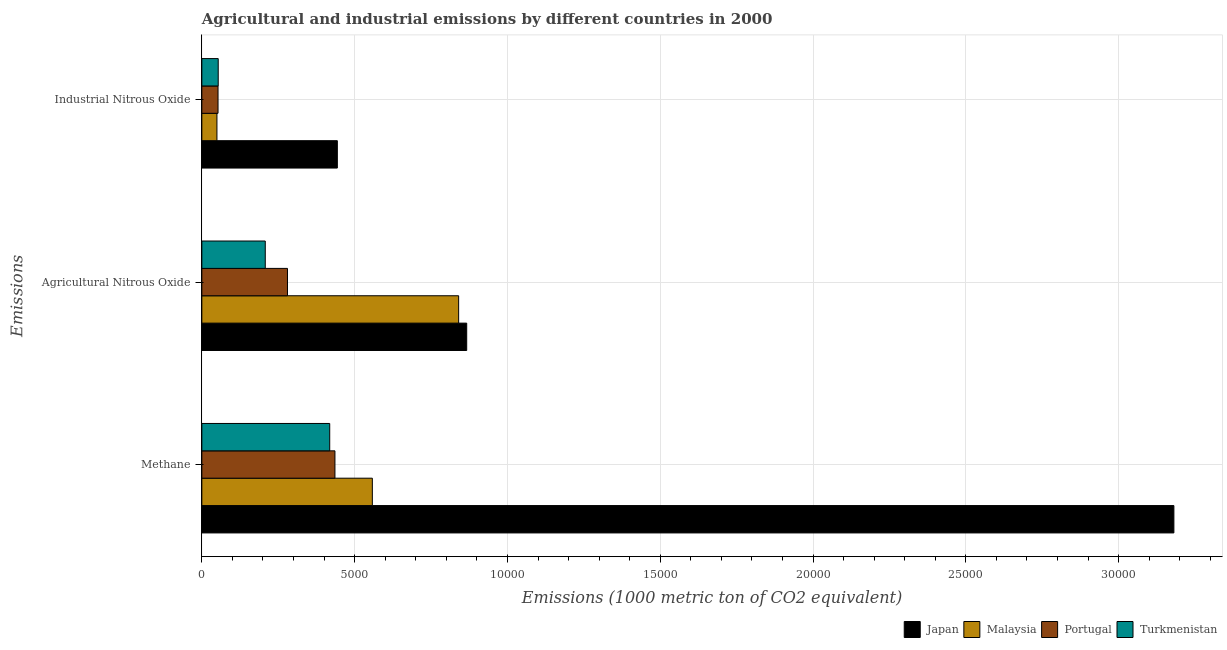How many different coloured bars are there?
Offer a very short reply. 4. What is the label of the 1st group of bars from the top?
Give a very brief answer. Industrial Nitrous Oxide. What is the amount of agricultural nitrous oxide emissions in Japan?
Provide a short and direct response. 8667.2. Across all countries, what is the maximum amount of industrial nitrous oxide emissions?
Give a very brief answer. 4433.9. Across all countries, what is the minimum amount of methane emissions?
Ensure brevity in your answer.  4184.3. In which country was the amount of industrial nitrous oxide emissions maximum?
Ensure brevity in your answer.  Japan. In which country was the amount of methane emissions minimum?
Give a very brief answer. Turkmenistan. What is the total amount of industrial nitrous oxide emissions in the graph?
Make the answer very short. 5992.9. What is the difference between the amount of methane emissions in Malaysia and that in Turkmenistan?
Keep it short and to the point. 1394.9. What is the difference between the amount of methane emissions in Turkmenistan and the amount of agricultural nitrous oxide emissions in Japan?
Your answer should be compact. -4482.9. What is the average amount of agricultural nitrous oxide emissions per country?
Keep it short and to the point. 5487.03. What is the difference between the amount of methane emissions and amount of agricultural nitrous oxide emissions in Turkmenistan?
Provide a short and direct response. 2109. In how many countries, is the amount of methane emissions greater than 7000 metric ton?
Provide a succinct answer. 1. What is the ratio of the amount of methane emissions in Japan to that in Turkmenistan?
Provide a succinct answer. 7.6. Is the difference between the amount of methane emissions in Malaysia and Turkmenistan greater than the difference between the amount of industrial nitrous oxide emissions in Malaysia and Turkmenistan?
Your answer should be compact. Yes. What is the difference between the highest and the second highest amount of industrial nitrous oxide emissions?
Your answer should be very brief. 3898.2. What is the difference between the highest and the lowest amount of industrial nitrous oxide emissions?
Your answer should be compact. 3940.1. In how many countries, is the amount of agricultural nitrous oxide emissions greater than the average amount of agricultural nitrous oxide emissions taken over all countries?
Offer a terse response. 2. What does the 1st bar from the bottom in Methane represents?
Your answer should be very brief. Japan. How many bars are there?
Make the answer very short. 12. Are all the bars in the graph horizontal?
Give a very brief answer. Yes. What is the difference between two consecutive major ticks on the X-axis?
Your answer should be compact. 5000. Are the values on the major ticks of X-axis written in scientific E-notation?
Your response must be concise. No. Does the graph contain grids?
Give a very brief answer. Yes. Where does the legend appear in the graph?
Offer a very short reply. Bottom right. What is the title of the graph?
Your response must be concise. Agricultural and industrial emissions by different countries in 2000. What is the label or title of the X-axis?
Offer a terse response. Emissions (1000 metric ton of CO2 equivalent). What is the label or title of the Y-axis?
Offer a very short reply. Emissions. What is the Emissions (1000 metric ton of CO2 equivalent) of Japan in Methane?
Give a very brief answer. 3.18e+04. What is the Emissions (1000 metric ton of CO2 equivalent) of Malaysia in Methane?
Your answer should be very brief. 5579.2. What is the Emissions (1000 metric ton of CO2 equivalent) in Portugal in Methane?
Ensure brevity in your answer.  4355.4. What is the Emissions (1000 metric ton of CO2 equivalent) of Turkmenistan in Methane?
Your answer should be compact. 4184.3. What is the Emissions (1000 metric ton of CO2 equivalent) of Japan in Agricultural Nitrous Oxide?
Provide a succinct answer. 8667.2. What is the Emissions (1000 metric ton of CO2 equivalent) of Malaysia in Agricultural Nitrous Oxide?
Keep it short and to the point. 8403.2. What is the Emissions (1000 metric ton of CO2 equivalent) of Portugal in Agricultural Nitrous Oxide?
Your answer should be compact. 2802.4. What is the Emissions (1000 metric ton of CO2 equivalent) in Turkmenistan in Agricultural Nitrous Oxide?
Provide a short and direct response. 2075.3. What is the Emissions (1000 metric ton of CO2 equivalent) of Japan in Industrial Nitrous Oxide?
Give a very brief answer. 4433.9. What is the Emissions (1000 metric ton of CO2 equivalent) in Malaysia in Industrial Nitrous Oxide?
Make the answer very short. 493.8. What is the Emissions (1000 metric ton of CO2 equivalent) of Portugal in Industrial Nitrous Oxide?
Ensure brevity in your answer.  529.5. What is the Emissions (1000 metric ton of CO2 equivalent) of Turkmenistan in Industrial Nitrous Oxide?
Keep it short and to the point. 535.7. Across all Emissions, what is the maximum Emissions (1000 metric ton of CO2 equivalent) in Japan?
Provide a short and direct response. 3.18e+04. Across all Emissions, what is the maximum Emissions (1000 metric ton of CO2 equivalent) in Malaysia?
Offer a very short reply. 8403.2. Across all Emissions, what is the maximum Emissions (1000 metric ton of CO2 equivalent) in Portugal?
Your answer should be compact. 4355.4. Across all Emissions, what is the maximum Emissions (1000 metric ton of CO2 equivalent) in Turkmenistan?
Keep it short and to the point. 4184.3. Across all Emissions, what is the minimum Emissions (1000 metric ton of CO2 equivalent) in Japan?
Your answer should be compact. 4433.9. Across all Emissions, what is the minimum Emissions (1000 metric ton of CO2 equivalent) of Malaysia?
Ensure brevity in your answer.  493.8. Across all Emissions, what is the minimum Emissions (1000 metric ton of CO2 equivalent) of Portugal?
Offer a terse response. 529.5. Across all Emissions, what is the minimum Emissions (1000 metric ton of CO2 equivalent) of Turkmenistan?
Your answer should be very brief. 535.7. What is the total Emissions (1000 metric ton of CO2 equivalent) of Japan in the graph?
Give a very brief answer. 4.49e+04. What is the total Emissions (1000 metric ton of CO2 equivalent) of Malaysia in the graph?
Provide a short and direct response. 1.45e+04. What is the total Emissions (1000 metric ton of CO2 equivalent) in Portugal in the graph?
Your response must be concise. 7687.3. What is the total Emissions (1000 metric ton of CO2 equivalent) in Turkmenistan in the graph?
Your response must be concise. 6795.3. What is the difference between the Emissions (1000 metric ton of CO2 equivalent) of Japan in Methane and that in Agricultural Nitrous Oxide?
Make the answer very short. 2.31e+04. What is the difference between the Emissions (1000 metric ton of CO2 equivalent) in Malaysia in Methane and that in Agricultural Nitrous Oxide?
Ensure brevity in your answer.  -2824. What is the difference between the Emissions (1000 metric ton of CO2 equivalent) of Portugal in Methane and that in Agricultural Nitrous Oxide?
Keep it short and to the point. 1553. What is the difference between the Emissions (1000 metric ton of CO2 equivalent) of Turkmenistan in Methane and that in Agricultural Nitrous Oxide?
Keep it short and to the point. 2109. What is the difference between the Emissions (1000 metric ton of CO2 equivalent) in Japan in Methane and that in Industrial Nitrous Oxide?
Provide a succinct answer. 2.74e+04. What is the difference between the Emissions (1000 metric ton of CO2 equivalent) in Malaysia in Methane and that in Industrial Nitrous Oxide?
Offer a very short reply. 5085.4. What is the difference between the Emissions (1000 metric ton of CO2 equivalent) in Portugal in Methane and that in Industrial Nitrous Oxide?
Offer a very short reply. 3825.9. What is the difference between the Emissions (1000 metric ton of CO2 equivalent) of Turkmenistan in Methane and that in Industrial Nitrous Oxide?
Keep it short and to the point. 3648.6. What is the difference between the Emissions (1000 metric ton of CO2 equivalent) of Japan in Agricultural Nitrous Oxide and that in Industrial Nitrous Oxide?
Make the answer very short. 4233.3. What is the difference between the Emissions (1000 metric ton of CO2 equivalent) in Malaysia in Agricultural Nitrous Oxide and that in Industrial Nitrous Oxide?
Offer a terse response. 7909.4. What is the difference between the Emissions (1000 metric ton of CO2 equivalent) in Portugal in Agricultural Nitrous Oxide and that in Industrial Nitrous Oxide?
Your response must be concise. 2272.9. What is the difference between the Emissions (1000 metric ton of CO2 equivalent) of Turkmenistan in Agricultural Nitrous Oxide and that in Industrial Nitrous Oxide?
Your answer should be compact. 1539.6. What is the difference between the Emissions (1000 metric ton of CO2 equivalent) of Japan in Methane and the Emissions (1000 metric ton of CO2 equivalent) of Malaysia in Agricultural Nitrous Oxide?
Offer a very short reply. 2.34e+04. What is the difference between the Emissions (1000 metric ton of CO2 equivalent) in Japan in Methane and the Emissions (1000 metric ton of CO2 equivalent) in Portugal in Agricultural Nitrous Oxide?
Offer a terse response. 2.90e+04. What is the difference between the Emissions (1000 metric ton of CO2 equivalent) of Japan in Methane and the Emissions (1000 metric ton of CO2 equivalent) of Turkmenistan in Agricultural Nitrous Oxide?
Your response must be concise. 2.97e+04. What is the difference between the Emissions (1000 metric ton of CO2 equivalent) of Malaysia in Methane and the Emissions (1000 metric ton of CO2 equivalent) of Portugal in Agricultural Nitrous Oxide?
Your answer should be very brief. 2776.8. What is the difference between the Emissions (1000 metric ton of CO2 equivalent) in Malaysia in Methane and the Emissions (1000 metric ton of CO2 equivalent) in Turkmenistan in Agricultural Nitrous Oxide?
Ensure brevity in your answer.  3503.9. What is the difference between the Emissions (1000 metric ton of CO2 equivalent) in Portugal in Methane and the Emissions (1000 metric ton of CO2 equivalent) in Turkmenistan in Agricultural Nitrous Oxide?
Offer a very short reply. 2280.1. What is the difference between the Emissions (1000 metric ton of CO2 equivalent) in Japan in Methane and the Emissions (1000 metric ton of CO2 equivalent) in Malaysia in Industrial Nitrous Oxide?
Your response must be concise. 3.13e+04. What is the difference between the Emissions (1000 metric ton of CO2 equivalent) in Japan in Methane and the Emissions (1000 metric ton of CO2 equivalent) in Portugal in Industrial Nitrous Oxide?
Make the answer very short. 3.13e+04. What is the difference between the Emissions (1000 metric ton of CO2 equivalent) in Japan in Methane and the Emissions (1000 metric ton of CO2 equivalent) in Turkmenistan in Industrial Nitrous Oxide?
Your answer should be compact. 3.13e+04. What is the difference between the Emissions (1000 metric ton of CO2 equivalent) in Malaysia in Methane and the Emissions (1000 metric ton of CO2 equivalent) in Portugal in Industrial Nitrous Oxide?
Your answer should be very brief. 5049.7. What is the difference between the Emissions (1000 metric ton of CO2 equivalent) in Malaysia in Methane and the Emissions (1000 metric ton of CO2 equivalent) in Turkmenistan in Industrial Nitrous Oxide?
Give a very brief answer. 5043.5. What is the difference between the Emissions (1000 metric ton of CO2 equivalent) in Portugal in Methane and the Emissions (1000 metric ton of CO2 equivalent) in Turkmenistan in Industrial Nitrous Oxide?
Provide a short and direct response. 3819.7. What is the difference between the Emissions (1000 metric ton of CO2 equivalent) in Japan in Agricultural Nitrous Oxide and the Emissions (1000 metric ton of CO2 equivalent) in Malaysia in Industrial Nitrous Oxide?
Offer a very short reply. 8173.4. What is the difference between the Emissions (1000 metric ton of CO2 equivalent) of Japan in Agricultural Nitrous Oxide and the Emissions (1000 metric ton of CO2 equivalent) of Portugal in Industrial Nitrous Oxide?
Keep it short and to the point. 8137.7. What is the difference between the Emissions (1000 metric ton of CO2 equivalent) in Japan in Agricultural Nitrous Oxide and the Emissions (1000 metric ton of CO2 equivalent) in Turkmenistan in Industrial Nitrous Oxide?
Offer a very short reply. 8131.5. What is the difference between the Emissions (1000 metric ton of CO2 equivalent) of Malaysia in Agricultural Nitrous Oxide and the Emissions (1000 metric ton of CO2 equivalent) of Portugal in Industrial Nitrous Oxide?
Your answer should be very brief. 7873.7. What is the difference between the Emissions (1000 metric ton of CO2 equivalent) in Malaysia in Agricultural Nitrous Oxide and the Emissions (1000 metric ton of CO2 equivalent) in Turkmenistan in Industrial Nitrous Oxide?
Keep it short and to the point. 7867.5. What is the difference between the Emissions (1000 metric ton of CO2 equivalent) of Portugal in Agricultural Nitrous Oxide and the Emissions (1000 metric ton of CO2 equivalent) of Turkmenistan in Industrial Nitrous Oxide?
Provide a short and direct response. 2266.7. What is the average Emissions (1000 metric ton of CO2 equivalent) in Japan per Emissions?
Ensure brevity in your answer.  1.50e+04. What is the average Emissions (1000 metric ton of CO2 equivalent) of Malaysia per Emissions?
Ensure brevity in your answer.  4825.4. What is the average Emissions (1000 metric ton of CO2 equivalent) in Portugal per Emissions?
Your answer should be compact. 2562.43. What is the average Emissions (1000 metric ton of CO2 equivalent) in Turkmenistan per Emissions?
Give a very brief answer. 2265.1. What is the difference between the Emissions (1000 metric ton of CO2 equivalent) of Japan and Emissions (1000 metric ton of CO2 equivalent) of Malaysia in Methane?
Give a very brief answer. 2.62e+04. What is the difference between the Emissions (1000 metric ton of CO2 equivalent) in Japan and Emissions (1000 metric ton of CO2 equivalent) in Portugal in Methane?
Your answer should be compact. 2.75e+04. What is the difference between the Emissions (1000 metric ton of CO2 equivalent) of Japan and Emissions (1000 metric ton of CO2 equivalent) of Turkmenistan in Methane?
Ensure brevity in your answer.  2.76e+04. What is the difference between the Emissions (1000 metric ton of CO2 equivalent) of Malaysia and Emissions (1000 metric ton of CO2 equivalent) of Portugal in Methane?
Give a very brief answer. 1223.8. What is the difference between the Emissions (1000 metric ton of CO2 equivalent) in Malaysia and Emissions (1000 metric ton of CO2 equivalent) in Turkmenistan in Methane?
Keep it short and to the point. 1394.9. What is the difference between the Emissions (1000 metric ton of CO2 equivalent) of Portugal and Emissions (1000 metric ton of CO2 equivalent) of Turkmenistan in Methane?
Ensure brevity in your answer.  171.1. What is the difference between the Emissions (1000 metric ton of CO2 equivalent) of Japan and Emissions (1000 metric ton of CO2 equivalent) of Malaysia in Agricultural Nitrous Oxide?
Provide a short and direct response. 264. What is the difference between the Emissions (1000 metric ton of CO2 equivalent) of Japan and Emissions (1000 metric ton of CO2 equivalent) of Portugal in Agricultural Nitrous Oxide?
Offer a very short reply. 5864.8. What is the difference between the Emissions (1000 metric ton of CO2 equivalent) of Japan and Emissions (1000 metric ton of CO2 equivalent) of Turkmenistan in Agricultural Nitrous Oxide?
Keep it short and to the point. 6591.9. What is the difference between the Emissions (1000 metric ton of CO2 equivalent) in Malaysia and Emissions (1000 metric ton of CO2 equivalent) in Portugal in Agricultural Nitrous Oxide?
Offer a very short reply. 5600.8. What is the difference between the Emissions (1000 metric ton of CO2 equivalent) of Malaysia and Emissions (1000 metric ton of CO2 equivalent) of Turkmenistan in Agricultural Nitrous Oxide?
Ensure brevity in your answer.  6327.9. What is the difference between the Emissions (1000 metric ton of CO2 equivalent) of Portugal and Emissions (1000 metric ton of CO2 equivalent) of Turkmenistan in Agricultural Nitrous Oxide?
Provide a short and direct response. 727.1. What is the difference between the Emissions (1000 metric ton of CO2 equivalent) of Japan and Emissions (1000 metric ton of CO2 equivalent) of Malaysia in Industrial Nitrous Oxide?
Provide a succinct answer. 3940.1. What is the difference between the Emissions (1000 metric ton of CO2 equivalent) of Japan and Emissions (1000 metric ton of CO2 equivalent) of Portugal in Industrial Nitrous Oxide?
Give a very brief answer. 3904.4. What is the difference between the Emissions (1000 metric ton of CO2 equivalent) in Japan and Emissions (1000 metric ton of CO2 equivalent) in Turkmenistan in Industrial Nitrous Oxide?
Offer a very short reply. 3898.2. What is the difference between the Emissions (1000 metric ton of CO2 equivalent) in Malaysia and Emissions (1000 metric ton of CO2 equivalent) in Portugal in Industrial Nitrous Oxide?
Offer a very short reply. -35.7. What is the difference between the Emissions (1000 metric ton of CO2 equivalent) of Malaysia and Emissions (1000 metric ton of CO2 equivalent) of Turkmenistan in Industrial Nitrous Oxide?
Offer a very short reply. -41.9. What is the difference between the Emissions (1000 metric ton of CO2 equivalent) in Portugal and Emissions (1000 metric ton of CO2 equivalent) in Turkmenistan in Industrial Nitrous Oxide?
Give a very brief answer. -6.2. What is the ratio of the Emissions (1000 metric ton of CO2 equivalent) of Japan in Methane to that in Agricultural Nitrous Oxide?
Keep it short and to the point. 3.67. What is the ratio of the Emissions (1000 metric ton of CO2 equivalent) of Malaysia in Methane to that in Agricultural Nitrous Oxide?
Make the answer very short. 0.66. What is the ratio of the Emissions (1000 metric ton of CO2 equivalent) in Portugal in Methane to that in Agricultural Nitrous Oxide?
Provide a succinct answer. 1.55. What is the ratio of the Emissions (1000 metric ton of CO2 equivalent) in Turkmenistan in Methane to that in Agricultural Nitrous Oxide?
Offer a terse response. 2.02. What is the ratio of the Emissions (1000 metric ton of CO2 equivalent) in Japan in Methane to that in Industrial Nitrous Oxide?
Offer a terse response. 7.17. What is the ratio of the Emissions (1000 metric ton of CO2 equivalent) of Malaysia in Methane to that in Industrial Nitrous Oxide?
Offer a very short reply. 11.3. What is the ratio of the Emissions (1000 metric ton of CO2 equivalent) of Portugal in Methane to that in Industrial Nitrous Oxide?
Ensure brevity in your answer.  8.23. What is the ratio of the Emissions (1000 metric ton of CO2 equivalent) in Turkmenistan in Methane to that in Industrial Nitrous Oxide?
Your response must be concise. 7.81. What is the ratio of the Emissions (1000 metric ton of CO2 equivalent) of Japan in Agricultural Nitrous Oxide to that in Industrial Nitrous Oxide?
Your response must be concise. 1.95. What is the ratio of the Emissions (1000 metric ton of CO2 equivalent) of Malaysia in Agricultural Nitrous Oxide to that in Industrial Nitrous Oxide?
Your response must be concise. 17.02. What is the ratio of the Emissions (1000 metric ton of CO2 equivalent) of Portugal in Agricultural Nitrous Oxide to that in Industrial Nitrous Oxide?
Provide a succinct answer. 5.29. What is the ratio of the Emissions (1000 metric ton of CO2 equivalent) in Turkmenistan in Agricultural Nitrous Oxide to that in Industrial Nitrous Oxide?
Make the answer very short. 3.87. What is the difference between the highest and the second highest Emissions (1000 metric ton of CO2 equivalent) in Japan?
Give a very brief answer. 2.31e+04. What is the difference between the highest and the second highest Emissions (1000 metric ton of CO2 equivalent) of Malaysia?
Offer a terse response. 2824. What is the difference between the highest and the second highest Emissions (1000 metric ton of CO2 equivalent) of Portugal?
Ensure brevity in your answer.  1553. What is the difference between the highest and the second highest Emissions (1000 metric ton of CO2 equivalent) of Turkmenistan?
Offer a terse response. 2109. What is the difference between the highest and the lowest Emissions (1000 metric ton of CO2 equivalent) in Japan?
Your answer should be compact. 2.74e+04. What is the difference between the highest and the lowest Emissions (1000 metric ton of CO2 equivalent) in Malaysia?
Your answer should be very brief. 7909.4. What is the difference between the highest and the lowest Emissions (1000 metric ton of CO2 equivalent) of Portugal?
Your answer should be compact. 3825.9. What is the difference between the highest and the lowest Emissions (1000 metric ton of CO2 equivalent) in Turkmenistan?
Make the answer very short. 3648.6. 